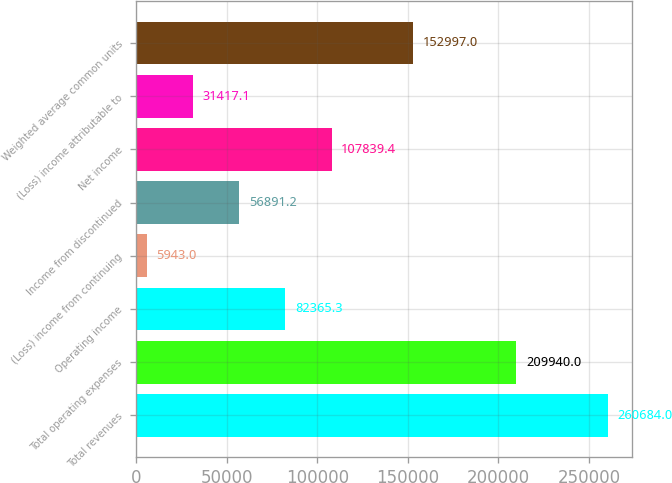<chart> <loc_0><loc_0><loc_500><loc_500><bar_chart><fcel>Total revenues<fcel>Total operating expenses<fcel>Operating income<fcel>(Loss) income from continuing<fcel>Income from discontinued<fcel>Net income<fcel>(Loss) income attributable to<fcel>Weighted average common units<nl><fcel>260684<fcel>209940<fcel>82365.3<fcel>5943<fcel>56891.2<fcel>107839<fcel>31417.1<fcel>152997<nl></chart> 